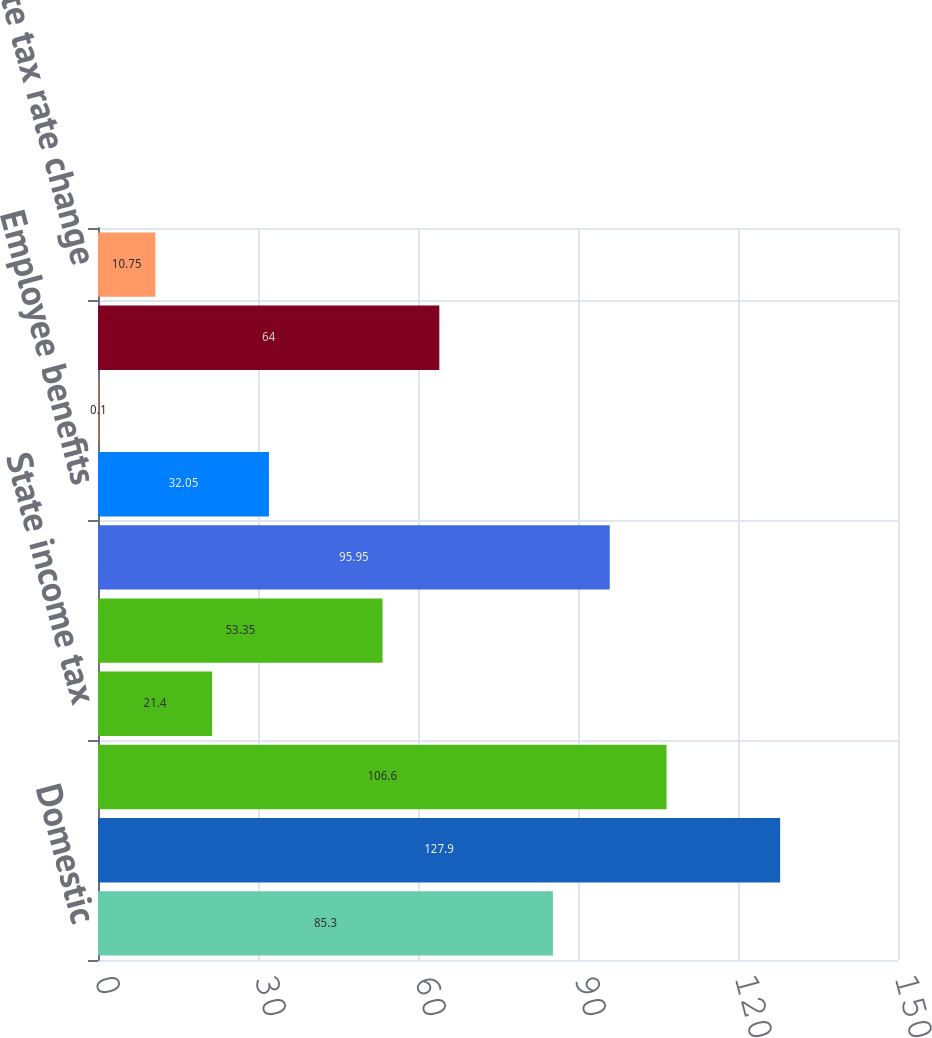<chart> <loc_0><loc_0><loc_500><loc_500><bar_chart><fcel>Domestic<fcel>Foreign<fcel>Tax expense at US statutory<fcel>State income tax<fcel>Tax on actual and planned<fcel>Foreign taxes less than US<fcel>Employee benefits<fcel>Other changes in valuation<fcel>Increase in unrecognized tax<fcel>State tax rate change<nl><fcel>85.3<fcel>127.9<fcel>106.6<fcel>21.4<fcel>53.35<fcel>95.95<fcel>32.05<fcel>0.1<fcel>64<fcel>10.75<nl></chart> 